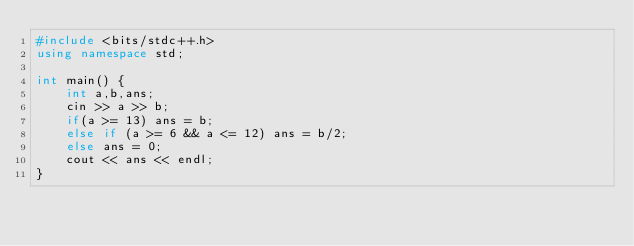<code> <loc_0><loc_0><loc_500><loc_500><_C++_>#include <bits/stdc++.h>
using namespace std;

int main() {
    int a,b,ans;
    cin >> a >> b;
    if(a >= 13) ans = b;
    else if (a >= 6 && a <= 12) ans = b/2;
    else ans = 0;
    cout << ans << endl;
}</code> 